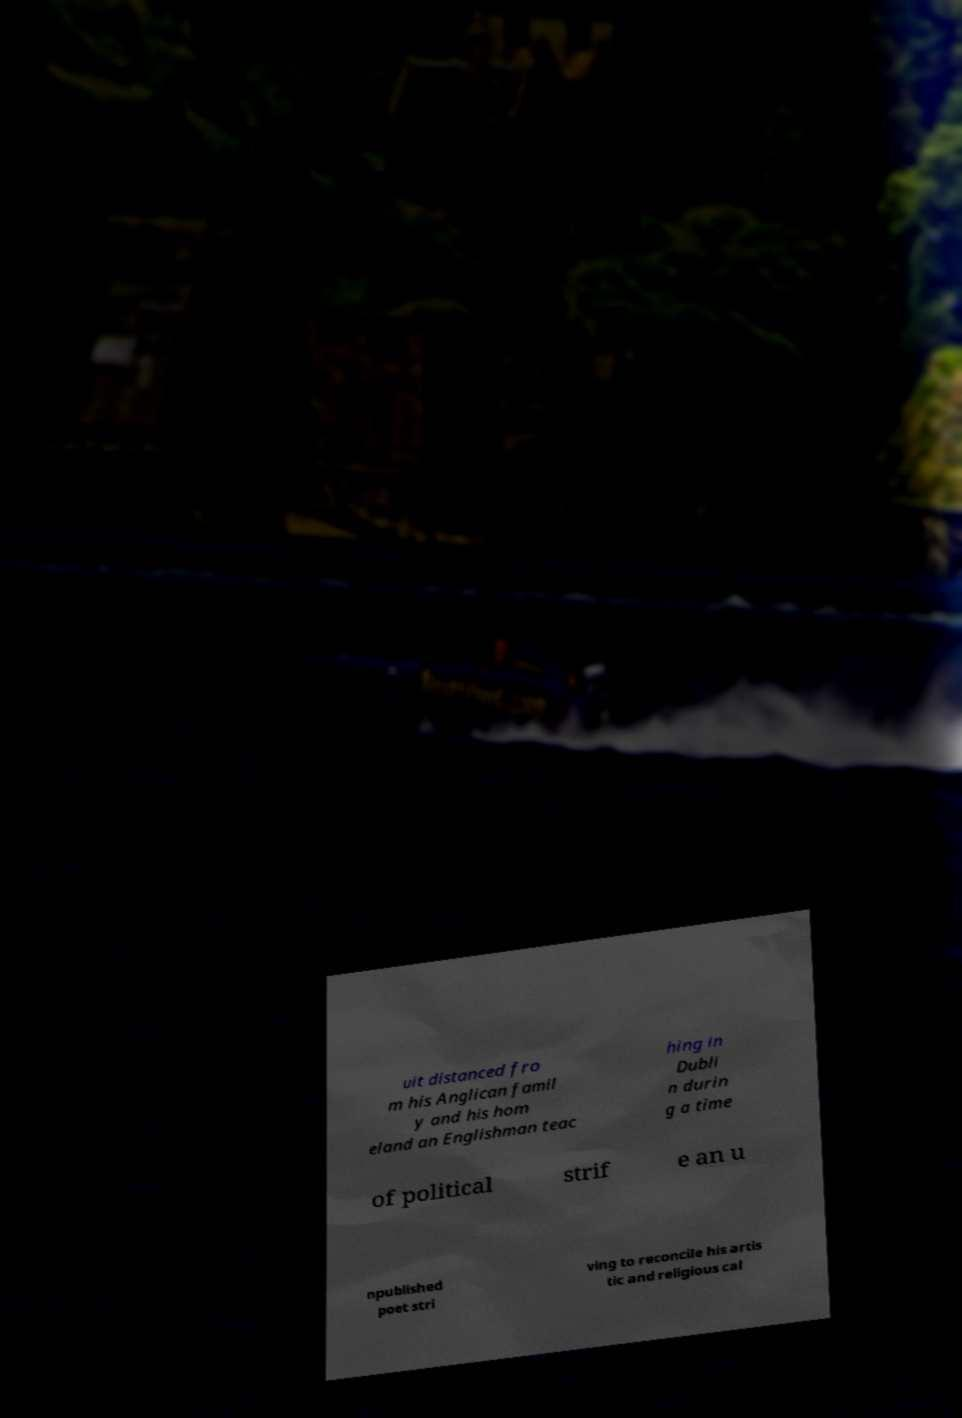Could you extract and type out the text from this image? uit distanced fro m his Anglican famil y and his hom eland an Englishman teac hing in Dubli n durin g a time of political strif e an u npublished poet stri ving to reconcile his artis tic and religious cal 